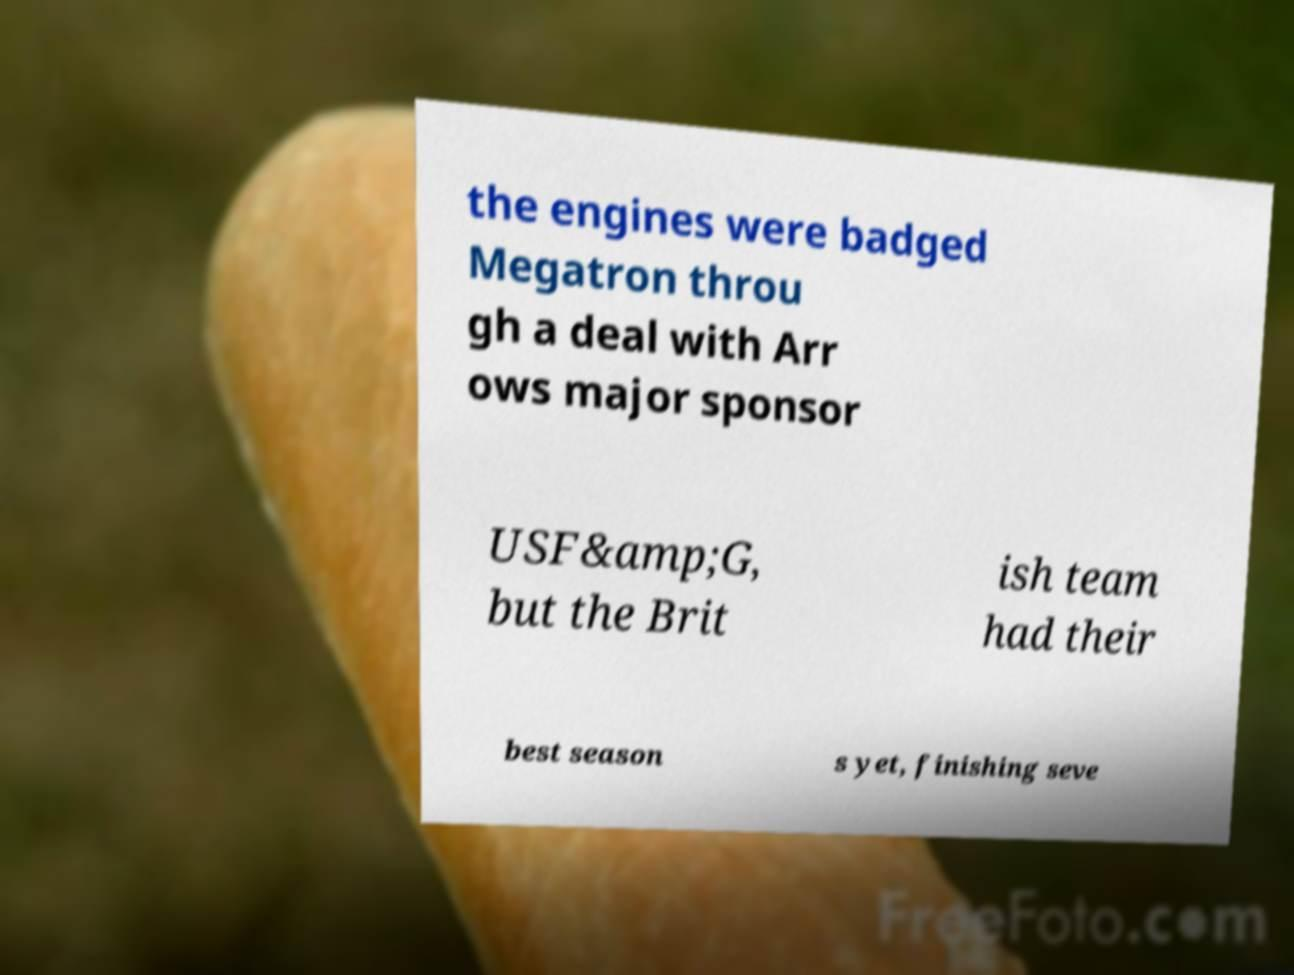I need the written content from this picture converted into text. Can you do that? the engines were badged Megatron throu gh a deal with Arr ows major sponsor USF&amp;G, but the Brit ish team had their best season s yet, finishing seve 